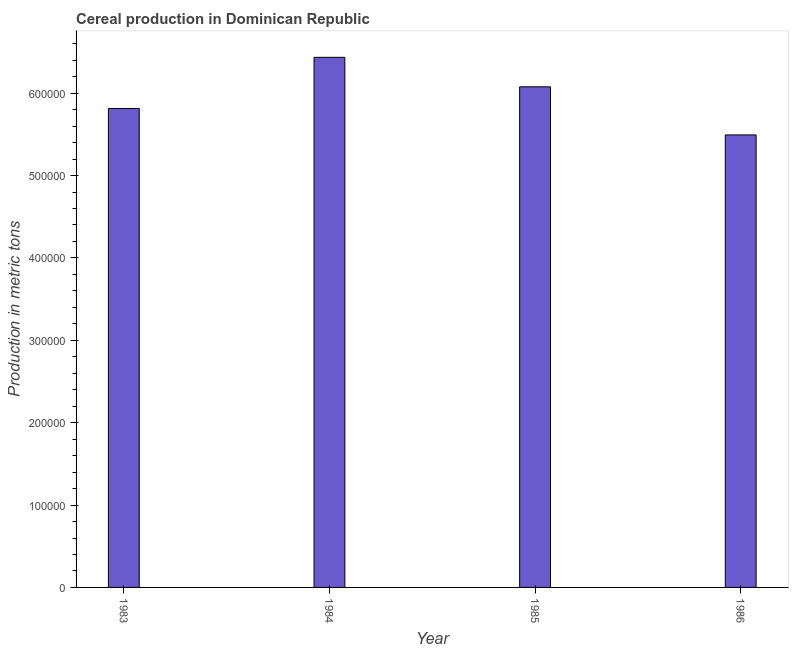Does the graph contain any zero values?
Provide a succinct answer. No. Does the graph contain grids?
Make the answer very short. No. What is the title of the graph?
Keep it short and to the point. Cereal production in Dominican Republic. What is the label or title of the Y-axis?
Provide a short and direct response. Production in metric tons. What is the cereal production in 1984?
Keep it short and to the point. 6.44e+05. Across all years, what is the maximum cereal production?
Give a very brief answer. 6.44e+05. Across all years, what is the minimum cereal production?
Give a very brief answer. 5.49e+05. In which year was the cereal production maximum?
Your answer should be compact. 1984. What is the sum of the cereal production?
Keep it short and to the point. 2.38e+06. What is the difference between the cereal production in 1984 and 1986?
Your answer should be very brief. 9.42e+04. What is the average cereal production per year?
Make the answer very short. 5.96e+05. What is the median cereal production?
Keep it short and to the point. 5.95e+05. In how many years, is the cereal production greater than 500000 metric tons?
Your answer should be compact. 4. Do a majority of the years between 1984 and 1985 (inclusive) have cereal production greater than 140000 metric tons?
Keep it short and to the point. Yes. What is the ratio of the cereal production in 1985 to that in 1986?
Your answer should be compact. 1.11. Is the cereal production in 1984 less than that in 1985?
Ensure brevity in your answer.  No. Is the difference between the cereal production in 1984 and 1986 greater than the difference between any two years?
Ensure brevity in your answer.  Yes. What is the difference between the highest and the second highest cereal production?
Provide a short and direct response. 3.58e+04. What is the difference between the highest and the lowest cereal production?
Give a very brief answer. 9.42e+04. In how many years, is the cereal production greater than the average cereal production taken over all years?
Provide a succinct answer. 2. How many bars are there?
Provide a short and direct response. 4. How many years are there in the graph?
Ensure brevity in your answer.  4. Are the values on the major ticks of Y-axis written in scientific E-notation?
Offer a terse response. No. What is the Production in metric tons in 1983?
Offer a very short reply. 5.81e+05. What is the Production in metric tons of 1984?
Keep it short and to the point. 6.44e+05. What is the Production in metric tons of 1985?
Make the answer very short. 6.08e+05. What is the Production in metric tons of 1986?
Keep it short and to the point. 5.49e+05. What is the difference between the Production in metric tons in 1983 and 1984?
Keep it short and to the point. -6.21e+04. What is the difference between the Production in metric tons in 1983 and 1985?
Keep it short and to the point. -2.63e+04. What is the difference between the Production in metric tons in 1983 and 1986?
Offer a very short reply. 3.21e+04. What is the difference between the Production in metric tons in 1984 and 1985?
Make the answer very short. 3.58e+04. What is the difference between the Production in metric tons in 1984 and 1986?
Your answer should be compact. 9.42e+04. What is the difference between the Production in metric tons in 1985 and 1986?
Ensure brevity in your answer.  5.84e+04. What is the ratio of the Production in metric tons in 1983 to that in 1984?
Offer a terse response. 0.9. What is the ratio of the Production in metric tons in 1983 to that in 1985?
Your answer should be compact. 0.96. What is the ratio of the Production in metric tons in 1983 to that in 1986?
Offer a terse response. 1.06. What is the ratio of the Production in metric tons in 1984 to that in 1985?
Give a very brief answer. 1.06. What is the ratio of the Production in metric tons in 1984 to that in 1986?
Give a very brief answer. 1.17. What is the ratio of the Production in metric tons in 1985 to that in 1986?
Your response must be concise. 1.11. 